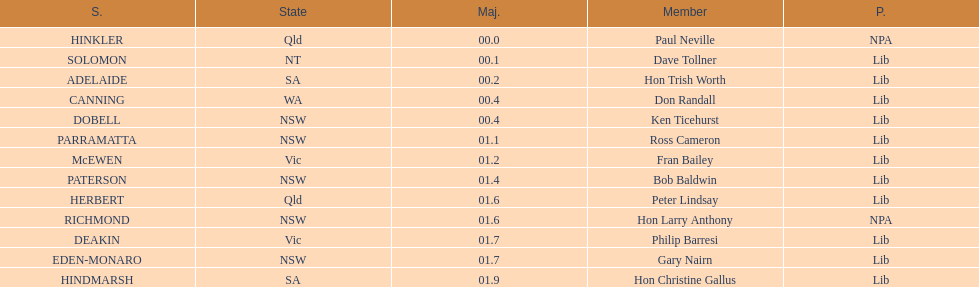What is the name of the last seat? HINDMARSH. 